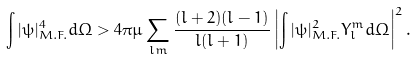<formula> <loc_0><loc_0><loc_500><loc_500>\int | \psi | ^ { 4 } _ { M . F . } d \Omega > 4 \pi \mu \sum _ { l m } \frac { ( l + 2 ) ( l - 1 ) } { l ( l + 1 ) } \left | \int | \psi | ^ { 2 } _ { M . F . } Y _ { l } ^ { m } d \Omega \right | ^ { 2 } .</formula> 